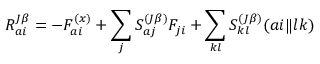Convert formula to latex. <formula><loc_0><loc_0><loc_500><loc_500>R _ { a i } ^ { J \beta } = - F _ { a i } ^ { ( x ) } + \sum _ { j } S _ { a j } ^ { ( J \beta ) } F _ { j i } + \sum _ { k l } S _ { k l } ^ { ( J \beta ) } ( a i \| l k )</formula> 